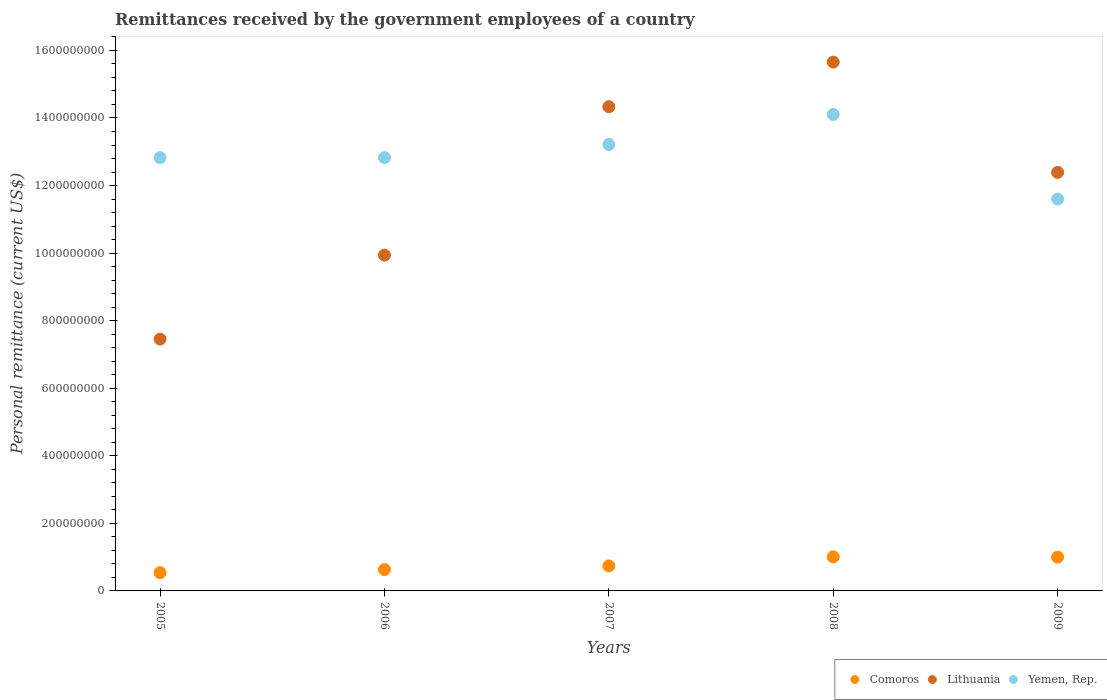Is the number of dotlines equal to the number of legend labels?
Provide a succinct answer. Yes. What is the remittances received by the government employees in Comoros in 2005?
Provide a short and direct response. 5.40e+07. Across all years, what is the maximum remittances received by the government employees in Comoros?
Offer a terse response. 1.01e+08. Across all years, what is the minimum remittances received by the government employees in Lithuania?
Provide a short and direct response. 7.45e+08. In which year was the remittances received by the government employees in Lithuania maximum?
Offer a very short reply. 2008. What is the total remittances received by the government employees in Yemen, Rep. in the graph?
Make the answer very short. 6.46e+09. What is the difference between the remittances received by the government employees in Comoros in 2007 and that in 2008?
Offer a terse response. -2.70e+07. What is the difference between the remittances received by the government employees in Lithuania in 2005 and the remittances received by the government employees in Yemen, Rep. in 2008?
Your answer should be very brief. -6.65e+08. What is the average remittances received by the government employees in Lithuania per year?
Your answer should be very brief. 1.20e+09. In the year 2008, what is the difference between the remittances received by the government employees in Yemen, Rep. and remittances received by the government employees in Lithuania?
Ensure brevity in your answer.  -1.55e+08. What is the ratio of the remittances received by the government employees in Lithuania in 2006 to that in 2009?
Ensure brevity in your answer.  0.8. Is the remittances received by the government employees in Comoros in 2006 less than that in 2007?
Ensure brevity in your answer.  Yes. Is the difference between the remittances received by the government employees in Yemen, Rep. in 2007 and 2009 greater than the difference between the remittances received by the government employees in Lithuania in 2007 and 2009?
Provide a succinct answer. No. What is the difference between the highest and the second highest remittances received by the government employees in Comoros?
Provide a short and direct response. 9.12e+05. What is the difference between the highest and the lowest remittances received by the government employees in Lithuania?
Offer a terse response. 8.20e+08. Is the remittances received by the government employees in Yemen, Rep. strictly less than the remittances received by the government employees in Lithuania over the years?
Your answer should be compact. No. How many dotlines are there?
Provide a succinct answer. 3. How many years are there in the graph?
Give a very brief answer. 5. Are the values on the major ticks of Y-axis written in scientific E-notation?
Give a very brief answer. No. Does the graph contain any zero values?
Ensure brevity in your answer.  No. What is the title of the graph?
Your answer should be compact. Remittances received by the government employees of a country. Does "Somalia" appear as one of the legend labels in the graph?
Provide a succinct answer. No. What is the label or title of the X-axis?
Provide a succinct answer. Years. What is the label or title of the Y-axis?
Provide a short and direct response. Personal remittance (current US$). What is the Personal remittance (current US$) of Comoros in 2005?
Offer a terse response. 5.40e+07. What is the Personal remittance (current US$) in Lithuania in 2005?
Give a very brief answer. 7.45e+08. What is the Personal remittance (current US$) of Yemen, Rep. in 2005?
Provide a short and direct response. 1.28e+09. What is the Personal remittance (current US$) of Comoros in 2006?
Provide a short and direct response. 6.31e+07. What is the Personal remittance (current US$) in Lithuania in 2006?
Your response must be concise. 9.94e+08. What is the Personal remittance (current US$) of Yemen, Rep. in 2006?
Ensure brevity in your answer.  1.28e+09. What is the Personal remittance (current US$) in Comoros in 2007?
Offer a very short reply. 7.39e+07. What is the Personal remittance (current US$) in Lithuania in 2007?
Ensure brevity in your answer.  1.43e+09. What is the Personal remittance (current US$) of Yemen, Rep. in 2007?
Your response must be concise. 1.32e+09. What is the Personal remittance (current US$) in Comoros in 2008?
Provide a short and direct response. 1.01e+08. What is the Personal remittance (current US$) in Lithuania in 2008?
Your answer should be compact. 1.57e+09. What is the Personal remittance (current US$) in Yemen, Rep. in 2008?
Make the answer very short. 1.41e+09. What is the Personal remittance (current US$) in Comoros in 2009?
Provide a succinct answer. 1.00e+08. What is the Personal remittance (current US$) in Lithuania in 2009?
Ensure brevity in your answer.  1.24e+09. What is the Personal remittance (current US$) of Yemen, Rep. in 2009?
Your answer should be compact. 1.16e+09. Across all years, what is the maximum Personal remittance (current US$) of Comoros?
Your answer should be compact. 1.01e+08. Across all years, what is the maximum Personal remittance (current US$) in Lithuania?
Provide a short and direct response. 1.57e+09. Across all years, what is the maximum Personal remittance (current US$) in Yemen, Rep.?
Your response must be concise. 1.41e+09. Across all years, what is the minimum Personal remittance (current US$) of Comoros?
Provide a succinct answer. 5.40e+07. Across all years, what is the minimum Personal remittance (current US$) of Lithuania?
Ensure brevity in your answer.  7.45e+08. Across all years, what is the minimum Personal remittance (current US$) of Yemen, Rep.?
Ensure brevity in your answer.  1.16e+09. What is the total Personal remittance (current US$) in Comoros in the graph?
Ensure brevity in your answer.  3.92e+08. What is the total Personal remittance (current US$) of Lithuania in the graph?
Offer a very short reply. 5.98e+09. What is the total Personal remittance (current US$) of Yemen, Rep. in the graph?
Your response must be concise. 6.46e+09. What is the difference between the Personal remittance (current US$) of Comoros in 2005 and that in 2006?
Make the answer very short. -9.11e+06. What is the difference between the Personal remittance (current US$) in Lithuania in 2005 and that in 2006?
Provide a short and direct response. -2.49e+08. What is the difference between the Personal remittance (current US$) in Yemen, Rep. in 2005 and that in 2006?
Your answer should be very brief. -1000. What is the difference between the Personal remittance (current US$) in Comoros in 2005 and that in 2007?
Your answer should be compact. -1.99e+07. What is the difference between the Personal remittance (current US$) in Lithuania in 2005 and that in 2007?
Offer a very short reply. -6.88e+08. What is the difference between the Personal remittance (current US$) of Yemen, Rep. in 2005 and that in 2007?
Offer a terse response. -3.89e+07. What is the difference between the Personal remittance (current US$) of Comoros in 2005 and that in 2008?
Offer a terse response. -4.69e+07. What is the difference between the Personal remittance (current US$) in Lithuania in 2005 and that in 2008?
Offer a terse response. -8.20e+08. What is the difference between the Personal remittance (current US$) in Yemen, Rep. in 2005 and that in 2008?
Offer a terse response. -1.28e+08. What is the difference between the Personal remittance (current US$) of Comoros in 2005 and that in 2009?
Offer a very short reply. -4.60e+07. What is the difference between the Personal remittance (current US$) in Lithuania in 2005 and that in 2009?
Give a very brief answer. -4.94e+08. What is the difference between the Personal remittance (current US$) of Yemen, Rep. in 2005 and that in 2009?
Ensure brevity in your answer.  1.23e+08. What is the difference between the Personal remittance (current US$) in Comoros in 2006 and that in 2007?
Your response must be concise. -1.08e+07. What is the difference between the Personal remittance (current US$) in Lithuania in 2006 and that in 2007?
Your response must be concise. -4.39e+08. What is the difference between the Personal remittance (current US$) of Yemen, Rep. in 2006 and that in 2007?
Ensure brevity in your answer.  -3.89e+07. What is the difference between the Personal remittance (current US$) of Comoros in 2006 and that in 2008?
Provide a short and direct response. -3.78e+07. What is the difference between the Personal remittance (current US$) of Lithuania in 2006 and that in 2008?
Provide a short and direct response. -5.71e+08. What is the difference between the Personal remittance (current US$) of Yemen, Rep. in 2006 and that in 2008?
Offer a very short reply. -1.28e+08. What is the difference between the Personal remittance (current US$) in Comoros in 2006 and that in 2009?
Provide a short and direct response. -3.69e+07. What is the difference between the Personal remittance (current US$) of Lithuania in 2006 and that in 2009?
Offer a terse response. -2.45e+08. What is the difference between the Personal remittance (current US$) of Yemen, Rep. in 2006 and that in 2009?
Ensure brevity in your answer.  1.23e+08. What is the difference between the Personal remittance (current US$) of Comoros in 2007 and that in 2008?
Provide a short and direct response. -2.70e+07. What is the difference between the Personal remittance (current US$) of Lithuania in 2007 and that in 2008?
Offer a very short reply. -1.32e+08. What is the difference between the Personal remittance (current US$) of Yemen, Rep. in 2007 and that in 2008?
Your answer should be very brief. -8.90e+07. What is the difference between the Personal remittance (current US$) of Comoros in 2007 and that in 2009?
Make the answer very short. -2.61e+07. What is the difference between the Personal remittance (current US$) in Lithuania in 2007 and that in 2009?
Ensure brevity in your answer.  1.94e+08. What is the difference between the Personal remittance (current US$) in Yemen, Rep. in 2007 and that in 2009?
Your answer should be compact. 1.62e+08. What is the difference between the Personal remittance (current US$) of Comoros in 2008 and that in 2009?
Give a very brief answer. 9.12e+05. What is the difference between the Personal remittance (current US$) in Lithuania in 2008 and that in 2009?
Ensure brevity in your answer.  3.26e+08. What is the difference between the Personal remittance (current US$) of Yemen, Rep. in 2008 and that in 2009?
Give a very brief answer. 2.51e+08. What is the difference between the Personal remittance (current US$) of Comoros in 2005 and the Personal remittance (current US$) of Lithuania in 2006?
Offer a terse response. -9.40e+08. What is the difference between the Personal remittance (current US$) in Comoros in 2005 and the Personal remittance (current US$) in Yemen, Rep. in 2006?
Make the answer very short. -1.23e+09. What is the difference between the Personal remittance (current US$) in Lithuania in 2005 and the Personal remittance (current US$) in Yemen, Rep. in 2006?
Your response must be concise. -5.37e+08. What is the difference between the Personal remittance (current US$) in Comoros in 2005 and the Personal remittance (current US$) in Lithuania in 2007?
Ensure brevity in your answer.  -1.38e+09. What is the difference between the Personal remittance (current US$) in Comoros in 2005 and the Personal remittance (current US$) in Yemen, Rep. in 2007?
Make the answer very short. -1.27e+09. What is the difference between the Personal remittance (current US$) in Lithuania in 2005 and the Personal remittance (current US$) in Yemen, Rep. in 2007?
Provide a succinct answer. -5.76e+08. What is the difference between the Personal remittance (current US$) in Comoros in 2005 and the Personal remittance (current US$) in Lithuania in 2008?
Keep it short and to the point. -1.51e+09. What is the difference between the Personal remittance (current US$) in Comoros in 2005 and the Personal remittance (current US$) in Yemen, Rep. in 2008?
Provide a succinct answer. -1.36e+09. What is the difference between the Personal remittance (current US$) of Lithuania in 2005 and the Personal remittance (current US$) of Yemen, Rep. in 2008?
Keep it short and to the point. -6.65e+08. What is the difference between the Personal remittance (current US$) of Comoros in 2005 and the Personal remittance (current US$) of Lithuania in 2009?
Offer a terse response. -1.19e+09. What is the difference between the Personal remittance (current US$) in Comoros in 2005 and the Personal remittance (current US$) in Yemen, Rep. in 2009?
Keep it short and to the point. -1.11e+09. What is the difference between the Personal remittance (current US$) of Lithuania in 2005 and the Personal remittance (current US$) of Yemen, Rep. in 2009?
Your answer should be very brief. -4.15e+08. What is the difference between the Personal remittance (current US$) in Comoros in 2006 and the Personal remittance (current US$) in Lithuania in 2007?
Offer a very short reply. -1.37e+09. What is the difference between the Personal remittance (current US$) of Comoros in 2006 and the Personal remittance (current US$) of Yemen, Rep. in 2007?
Make the answer very short. -1.26e+09. What is the difference between the Personal remittance (current US$) of Lithuania in 2006 and the Personal remittance (current US$) of Yemen, Rep. in 2007?
Make the answer very short. -3.27e+08. What is the difference between the Personal remittance (current US$) of Comoros in 2006 and the Personal remittance (current US$) of Lithuania in 2008?
Your answer should be very brief. -1.50e+09. What is the difference between the Personal remittance (current US$) of Comoros in 2006 and the Personal remittance (current US$) of Yemen, Rep. in 2008?
Provide a short and direct response. -1.35e+09. What is the difference between the Personal remittance (current US$) in Lithuania in 2006 and the Personal remittance (current US$) in Yemen, Rep. in 2008?
Offer a terse response. -4.16e+08. What is the difference between the Personal remittance (current US$) of Comoros in 2006 and the Personal remittance (current US$) of Lithuania in 2009?
Give a very brief answer. -1.18e+09. What is the difference between the Personal remittance (current US$) of Comoros in 2006 and the Personal remittance (current US$) of Yemen, Rep. in 2009?
Ensure brevity in your answer.  -1.10e+09. What is the difference between the Personal remittance (current US$) in Lithuania in 2006 and the Personal remittance (current US$) in Yemen, Rep. in 2009?
Ensure brevity in your answer.  -1.66e+08. What is the difference between the Personal remittance (current US$) in Comoros in 2007 and the Personal remittance (current US$) in Lithuania in 2008?
Offer a very short reply. -1.49e+09. What is the difference between the Personal remittance (current US$) of Comoros in 2007 and the Personal remittance (current US$) of Yemen, Rep. in 2008?
Make the answer very short. -1.34e+09. What is the difference between the Personal remittance (current US$) of Lithuania in 2007 and the Personal remittance (current US$) of Yemen, Rep. in 2008?
Give a very brief answer. 2.28e+07. What is the difference between the Personal remittance (current US$) in Comoros in 2007 and the Personal remittance (current US$) in Lithuania in 2009?
Offer a very short reply. -1.17e+09. What is the difference between the Personal remittance (current US$) of Comoros in 2007 and the Personal remittance (current US$) of Yemen, Rep. in 2009?
Ensure brevity in your answer.  -1.09e+09. What is the difference between the Personal remittance (current US$) of Lithuania in 2007 and the Personal remittance (current US$) of Yemen, Rep. in 2009?
Give a very brief answer. 2.73e+08. What is the difference between the Personal remittance (current US$) in Comoros in 2008 and the Personal remittance (current US$) in Lithuania in 2009?
Make the answer very short. -1.14e+09. What is the difference between the Personal remittance (current US$) of Comoros in 2008 and the Personal remittance (current US$) of Yemen, Rep. in 2009?
Your response must be concise. -1.06e+09. What is the difference between the Personal remittance (current US$) in Lithuania in 2008 and the Personal remittance (current US$) in Yemen, Rep. in 2009?
Give a very brief answer. 4.05e+08. What is the average Personal remittance (current US$) in Comoros per year?
Your answer should be compact. 7.84e+07. What is the average Personal remittance (current US$) in Lithuania per year?
Make the answer very short. 1.20e+09. What is the average Personal remittance (current US$) in Yemen, Rep. per year?
Give a very brief answer. 1.29e+09. In the year 2005, what is the difference between the Personal remittance (current US$) in Comoros and Personal remittance (current US$) in Lithuania?
Make the answer very short. -6.91e+08. In the year 2005, what is the difference between the Personal remittance (current US$) of Comoros and Personal remittance (current US$) of Yemen, Rep.?
Provide a succinct answer. -1.23e+09. In the year 2005, what is the difference between the Personal remittance (current US$) of Lithuania and Personal remittance (current US$) of Yemen, Rep.?
Make the answer very short. -5.37e+08. In the year 2006, what is the difference between the Personal remittance (current US$) of Comoros and Personal remittance (current US$) of Lithuania?
Provide a short and direct response. -9.31e+08. In the year 2006, what is the difference between the Personal remittance (current US$) in Comoros and Personal remittance (current US$) in Yemen, Rep.?
Give a very brief answer. -1.22e+09. In the year 2006, what is the difference between the Personal remittance (current US$) of Lithuania and Personal remittance (current US$) of Yemen, Rep.?
Offer a terse response. -2.89e+08. In the year 2007, what is the difference between the Personal remittance (current US$) of Comoros and Personal remittance (current US$) of Lithuania?
Give a very brief answer. -1.36e+09. In the year 2007, what is the difference between the Personal remittance (current US$) of Comoros and Personal remittance (current US$) of Yemen, Rep.?
Keep it short and to the point. -1.25e+09. In the year 2007, what is the difference between the Personal remittance (current US$) in Lithuania and Personal remittance (current US$) in Yemen, Rep.?
Your response must be concise. 1.12e+08. In the year 2008, what is the difference between the Personal remittance (current US$) in Comoros and Personal remittance (current US$) in Lithuania?
Your answer should be compact. -1.46e+09. In the year 2008, what is the difference between the Personal remittance (current US$) of Comoros and Personal remittance (current US$) of Yemen, Rep.?
Provide a short and direct response. -1.31e+09. In the year 2008, what is the difference between the Personal remittance (current US$) in Lithuania and Personal remittance (current US$) in Yemen, Rep.?
Offer a very short reply. 1.55e+08. In the year 2009, what is the difference between the Personal remittance (current US$) in Comoros and Personal remittance (current US$) in Lithuania?
Offer a very short reply. -1.14e+09. In the year 2009, what is the difference between the Personal remittance (current US$) in Comoros and Personal remittance (current US$) in Yemen, Rep.?
Provide a succinct answer. -1.06e+09. In the year 2009, what is the difference between the Personal remittance (current US$) of Lithuania and Personal remittance (current US$) of Yemen, Rep.?
Your response must be concise. 7.91e+07. What is the ratio of the Personal remittance (current US$) of Comoros in 2005 to that in 2006?
Give a very brief answer. 0.86. What is the ratio of the Personal remittance (current US$) of Lithuania in 2005 to that in 2006?
Your answer should be compact. 0.75. What is the ratio of the Personal remittance (current US$) in Yemen, Rep. in 2005 to that in 2006?
Give a very brief answer. 1. What is the ratio of the Personal remittance (current US$) in Comoros in 2005 to that in 2007?
Your response must be concise. 0.73. What is the ratio of the Personal remittance (current US$) in Lithuania in 2005 to that in 2007?
Give a very brief answer. 0.52. What is the ratio of the Personal remittance (current US$) in Yemen, Rep. in 2005 to that in 2007?
Ensure brevity in your answer.  0.97. What is the ratio of the Personal remittance (current US$) of Comoros in 2005 to that in 2008?
Ensure brevity in your answer.  0.54. What is the ratio of the Personal remittance (current US$) in Lithuania in 2005 to that in 2008?
Offer a very short reply. 0.48. What is the ratio of the Personal remittance (current US$) of Yemen, Rep. in 2005 to that in 2008?
Your answer should be very brief. 0.91. What is the ratio of the Personal remittance (current US$) of Comoros in 2005 to that in 2009?
Offer a terse response. 0.54. What is the ratio of the Personal remittance (current US$) of Lithuania in 2005 to that in 2009?
Your response must be concise. 0.6. What is the ratio of the Personal remittance (current US$) in Yemen, Rep. in 2005 to that in 2009?
Make the answer very short. 1.11. What is the ratio of the Personal remittance (current US$) in Comoros in 2006 to that in 2007?
Provide a succinct answer. 0.85. What is the ratio of the Personal remittance (current US$) in Lithuania in 2006 to that in 2007?
Make the answer very short. 0.69. What is the ratio of the Personal remittance (current US$) of Yemen, Rep. in 2006 to that in 2007?
Your answer should be very brief. 0.97. What is the ratio of the Personal remittance (current US$) of Comoros in 2006 to that in 2008?
Make the answer very short. 0.63. What is the ratio of the Personal remittance (current US$) of Lithuania in 2006 to that in 2008?
Keep it short and to the point. 0.64. What is the ratio of the Personal remittance (current US$) in Yemen, Rep. in 2006 to that in 2008?
Give a very brief answer. 0.91. What is the ratio of the Personal remittance (current US$) in Comoros in 2006 to that in 2009?
Ensure brevity in your answer.  0.63. What is the ratio of the Personal remittance (current US$) in Lithuania in 2006 to that in 2009?
Your answer should be compact. 0.8. What is the ratio of the Personal remittance (current US$) of Yemen, Rep. in 2006 to that in 2009?
Your response must be concise. 1.11. What is the ratio of the Personal remittance (current US$) in Comoros in 2007 to that in 2008?
Your answer should be compact. 0.73. What is the ratio of the Personal remittance (current US$) in Lithuania in 2007 to that in 2008?
Your response must be concise. 0.92. What is the ratio of the Personal remittance (current US$) of Yemen, Rep. in 2007 to that in 2008?
Offer a very short reply. 0.94. What is the ratio of the Personal remittance (current US$) of Comoros in 2007 to that in 2009?
Your response must be concise. 0.74. What is the ratio of the Personal remittance (current US$) in Lithuania in 2007 to that in 2009?
Your answer should be compact. 1.16. What is the ratio of the Personal remittance (current US$) of Yemen, Rep. in 2007 to that in 2009?
Your response must be concise. 1.14. What is the ratio of the Personal remittance (current US$) of Comoros in 2008 to that in 2009?
Provide a short and direct response. 1.01. What is the ratio of the Personal remittance (current US$) in Lithuania in 2008 to that in 2009?
Your answer should be very brief. 1.26. What is the ratio of the Personal remittance (current US$) in Yemen, Rep. in 2008 to that in 2009?
Offer a terse response. 1.22. What is the difference between the highest and the second highest Personal remittance (current US$) in Comoros?
Ensure brevity in your answer.  9.12e+05. What is the difference between the highest and the second highest Personal remittance (current US$) in Lithuania?
Ensure brevity in your answer.  1.32e+08. What is the difference between the highest and the second highest Personal remittance (current US$) in Yemen, Rep.?
Keep it short and to the point. 8.90e+07. What is the difference between the highest and the lowest Personal remittance (current US$) in Comoros?
Give a very brief answer. 4.69e+07. What is the difference between the highest and the lowest Personal remittance (current US$) of Lithuania?
Provide a short and direct response. 8.20e+08. What is the difference between the highest and the lowest Personal remittance (current US$) of Yemen, Rep.?
Provide a short and direct response. 2.51e+08. 